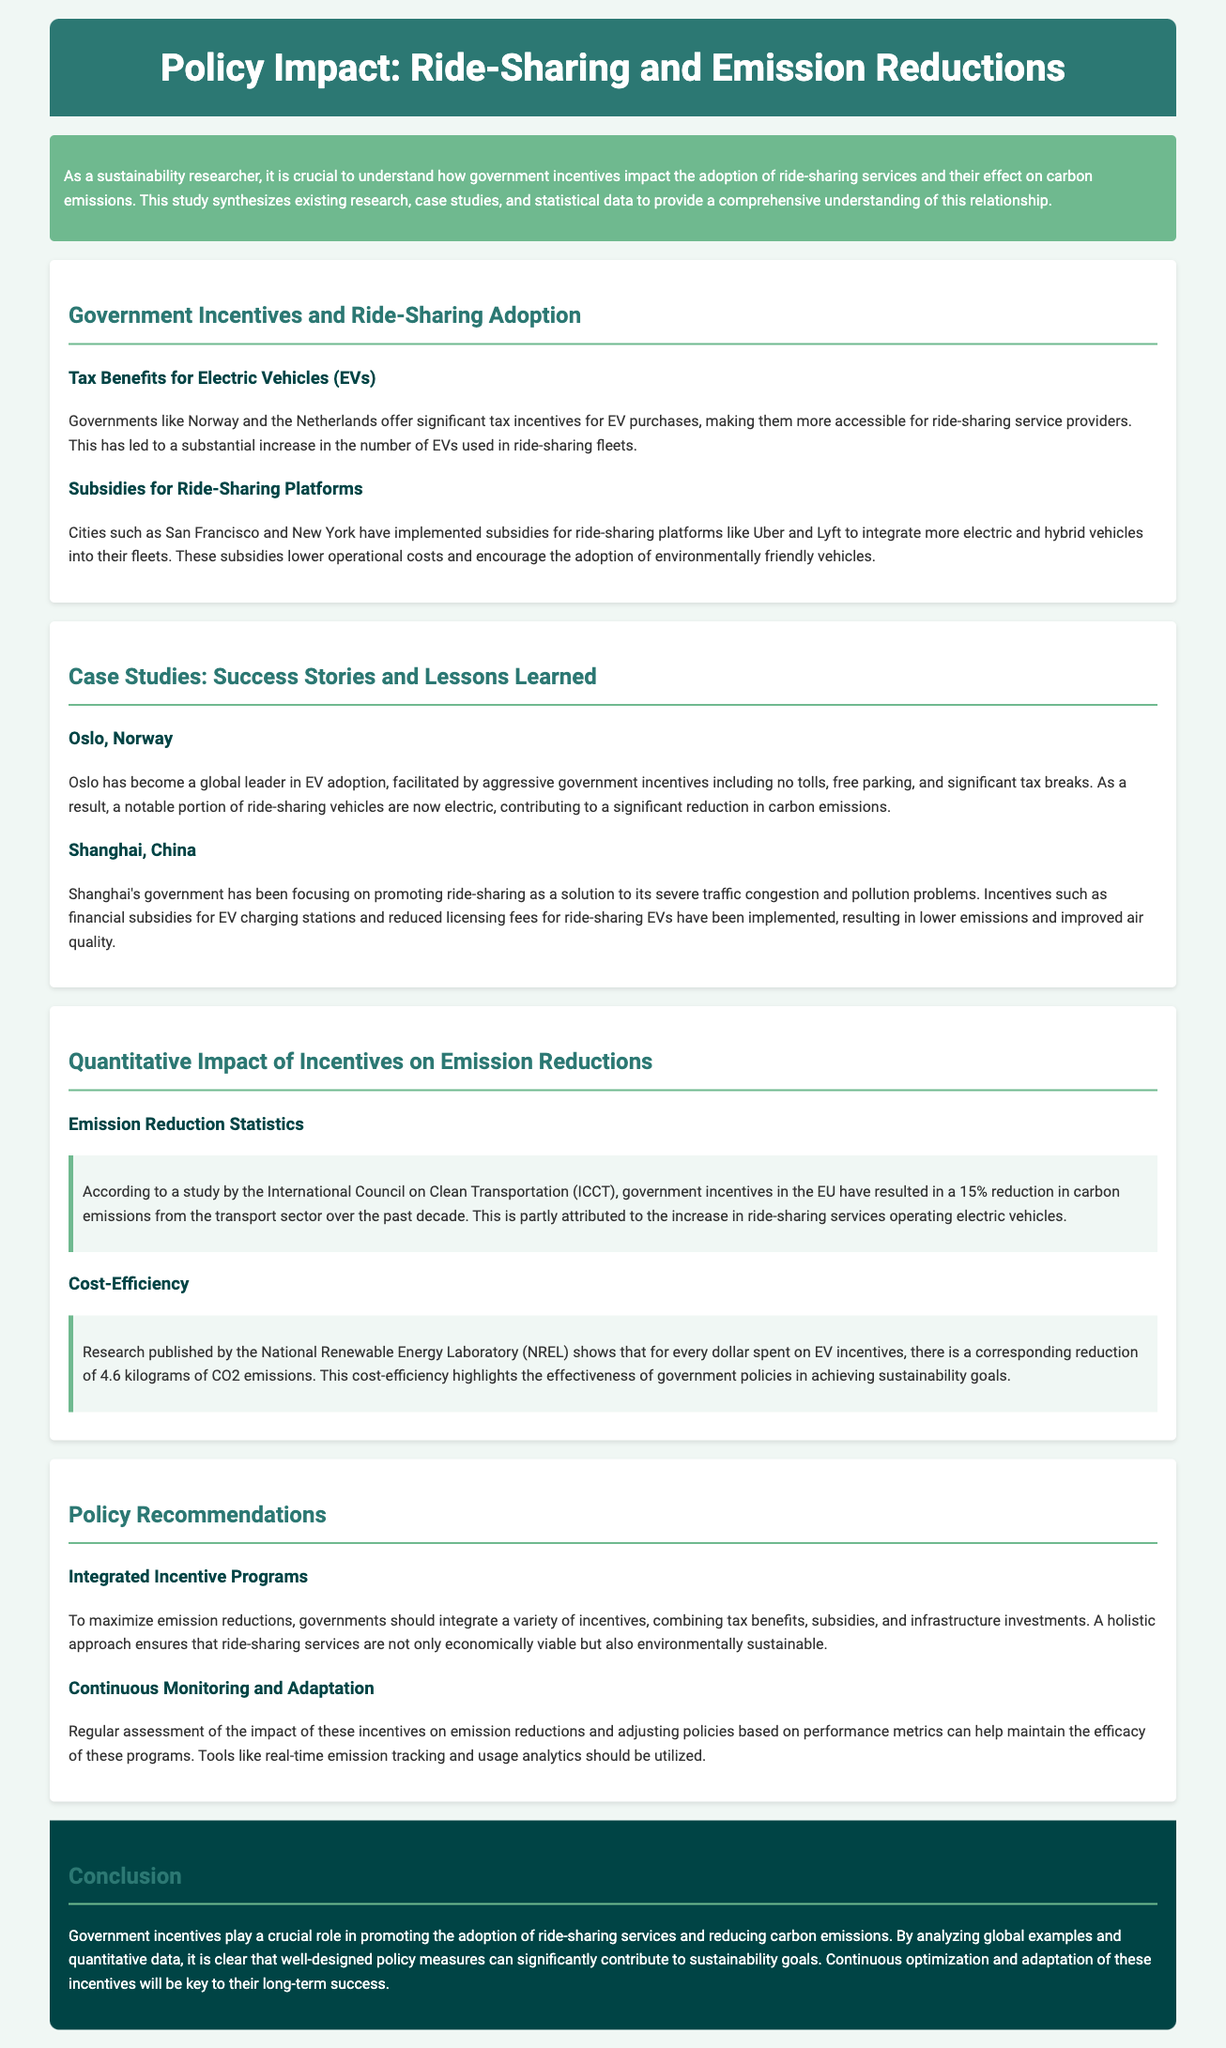What are two countries that offer tax incentives for EVs? The document mentions Norway and the Netherlands as examples of countries that provide significant tax incentives for electric vehicles.
Answer: Norway, Netherlands What city implemented subsidies for ride-sharing platforms like Uber and Lyft? San Francisco and New York are cities noted for implementing subsidies for ride-sharing platforms to encourage the use of electric and hybrid vehicles.
Answer: San Francisco, New York What percentage reduction in carbon emissions has been reported due to government incentives in the EU? According to the ICCT, government incentives in the EU have resulted in a 15% reduction in carbon emissions from the transport sector.
Answer: 15% What is the cost efficiency ratio of EV incentives according to NREL? The National Renewable Energy Laboratory indicates that for every dollar spent on EV incentives, there is a corresponding reduction of 4.6 kilograms of CO2 emissions.
Answer: 4.6 kilograms Which city is highlighted as a global leader in EV adoption? Oslo is described as a global leader in electric vehicle adoption due to aggressive government incentives.
Answer: Oslo What should governments do to maximize emission reductions? The document recommends that governments should integrate a variety of incentives, combining tax benefits, subsidies, and infrastructure investments.
Answer: Integrate a variety of incentives What role do government incentives play in ride-sharing services? Government incentives are crucial for promoting the adoption of ride-sharing services and reducing carbon emissions.
Answer: Crucial role What type of monitoring is suggested for maintaining policy efficacy? The document recommends continuous monitoring and adaptation of incentives based on performance metrics and real-time emission tracking.
Answer: Continuous monitoring and adaptation 